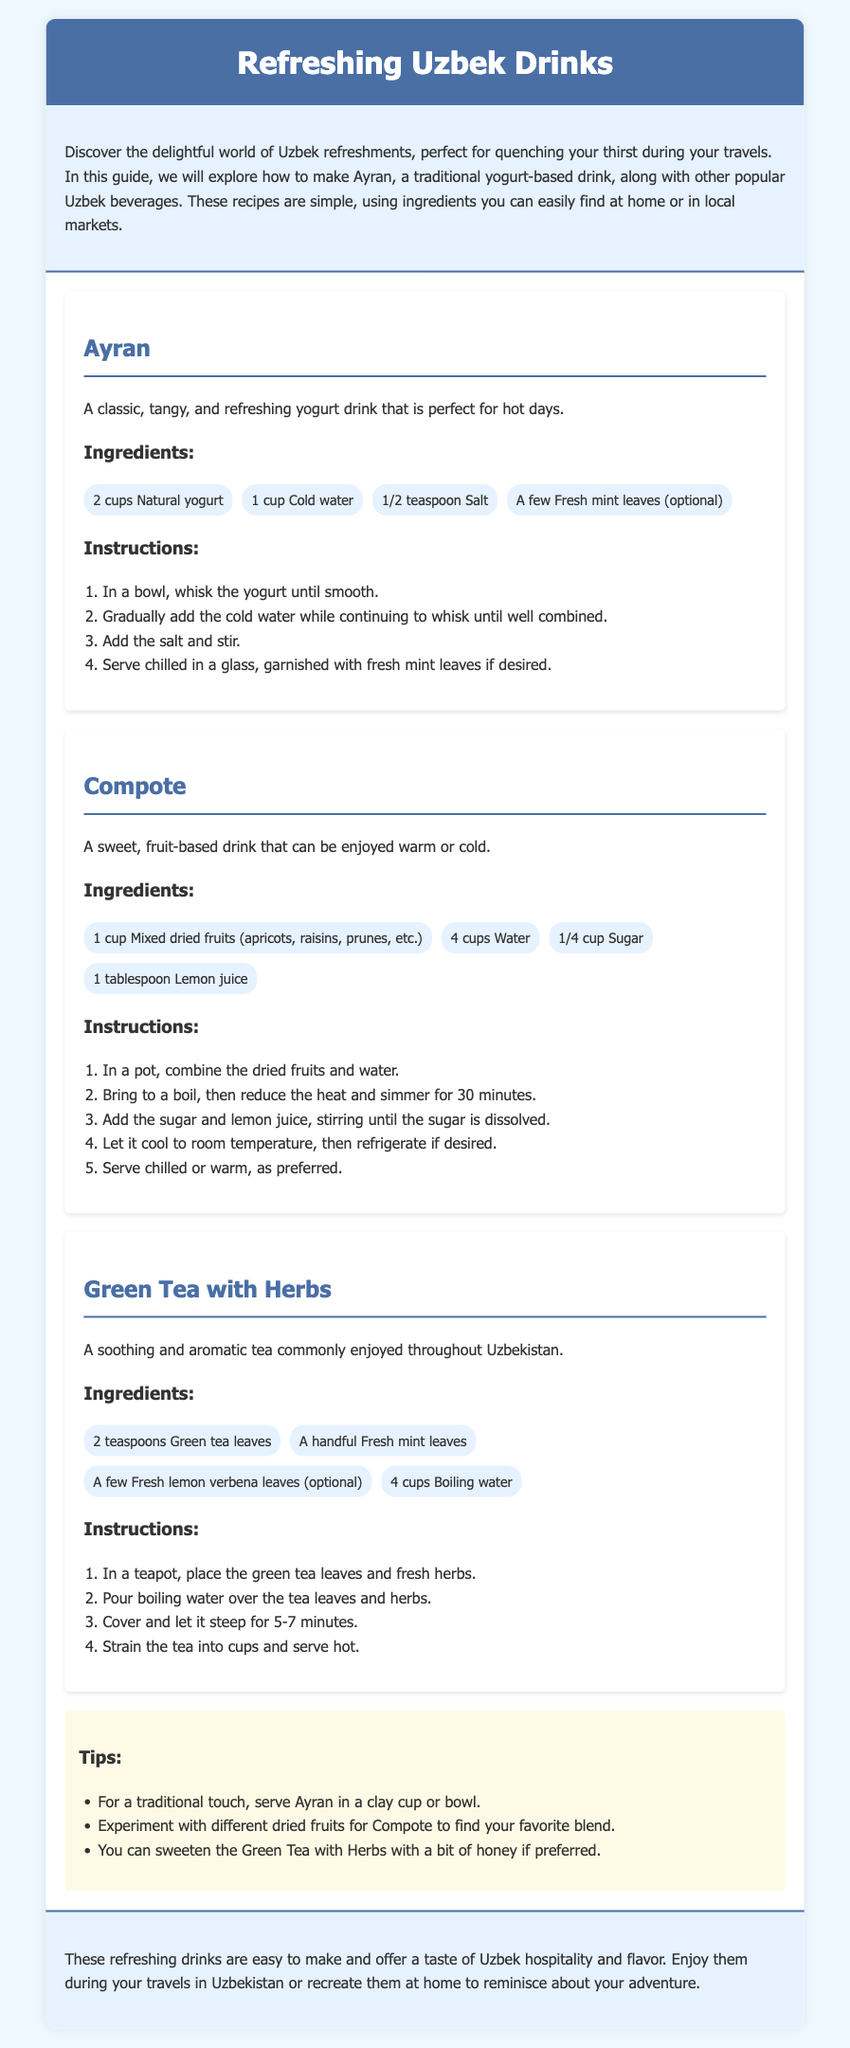What is Ayran? Ayran is a classic, tangy, and refreshing yogurt drink that is perfect for hot days.
Answer: A classic yogurt drink How many cups of water are needed for Compote? The recipe for Compote specifies using 4 cups of water.
Answer: 4 cups What optional ingredient can be added to Ayran? The recipe mentions that fresh mint leaves can be added optionally.
Answer: Fresh mint leaves What is the steeping time for Green Tea with Herbs? It should steep for 5-7 minutes according to the instructions.
Answer: 5-7 minutes How many ingredients are listed for Green Tea with Herbs? There are 4 ingredients specified in the Green Tea with Herbs recipe.
Answer: 4 ingredients Which drink is a sweet, fruit-based beverage? The document states that Compote is a sweet, fruit-based drink.
Answer: Compote What is the purpose of the tips section? The tips section provides helpful suggestions for enhancing the drink recipes.
Answer: Helpful suggestions What does the conclusion suggest to do with these drinks? The conclusion suggests enjoying the drinks during travels or recreating them at home.
Answer: Enjoy during travels or recreate at home 